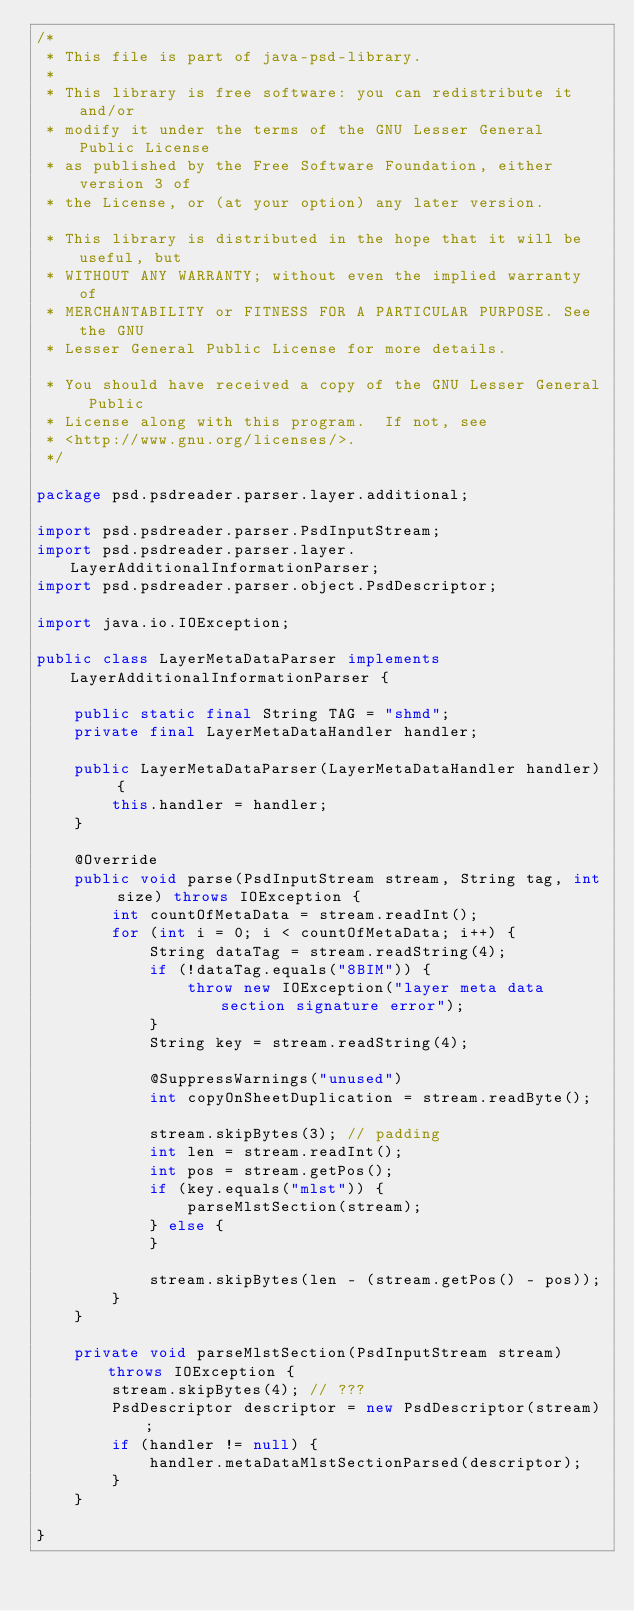<code> <loc_0><loc_0><loc_500><loc_500><_Java_>/*
 * This file is part of java-psd-library.
 * 
 * This library is free software: you can redistribute it and/or
 * modify it under the terms of the GNU Lesser General Public License
 * as published by the Free Software Foundation, either version 3 of
 * the License, or (at your option) any later version.

 * This library is distributed in the hope that it will be useful, but
 * WITHOUT ANY WARRANTY; without even the implied warranty of
 * MERCHANTABILITY or FITNESS FOR A PARTICULAR PURPOSE. See the GNU
 * Lesser General Public License for more details.

 * You should have received a copy of the GNU Lesser General Public
 * License along with this program.  If not, see
 * <http://www.gnu.org/licenses/>.
 */

package psd.psdreader.parser.layer.additional;

import psd.psdreader.parser.PsdInputStream;
import psd.psdreader.parser.layer.LayerAdditionalInformationParser;
import psd.psdreader.parser.object.PsdDescriptor;

import java.io.IOException;

public class LayerMetaDataParser implements LayerAdditionalInformationParser {

	public static final String TAG = "shmd";
	private final LayerMetaDataHandler handler;
	
	public LayerMetaDataParser(LayerMetaDataHandler handler) {
		this.handler = handler;
	}

	@Override
	public void parse(PsdInputStream stream, String tag, int size) throws IOException {
		int countOfMetaData = stream.readInt();
		for (int i = 0; i < countOfMetaData; i++) {
			String dataTag = stream.readString(4);
			if (!dataTag.equals("8BIM")) {
				throw new IOException("layer meta data section signature error");
			}
			String key = stream.readString(4);
			
			@SuppressWarnings("unused")
			int copyOnSheetDuplication = stream.readByte();
			
			stream.skipBytes(3); // padding
			int len = stream.readInt();
			int pos = stream.getPos();
			if (key.equals("mlst")) {
				parseMlstSection(stream);
			} else {
			}

			stream.skipBytes(len - (stream.getPos() - pos));
		}
	}
	
	private void parseMlstSection(PsdInputStream stream) throws IOException {
		stream.skipBytes(4); // ???
		PsdDescriptor descriptor = new PsdDescriptor(stream);
		if (handler != null) {
			handler.metaDataMlstSectionParsed(descriptor);
		}
	}

}
</code> 